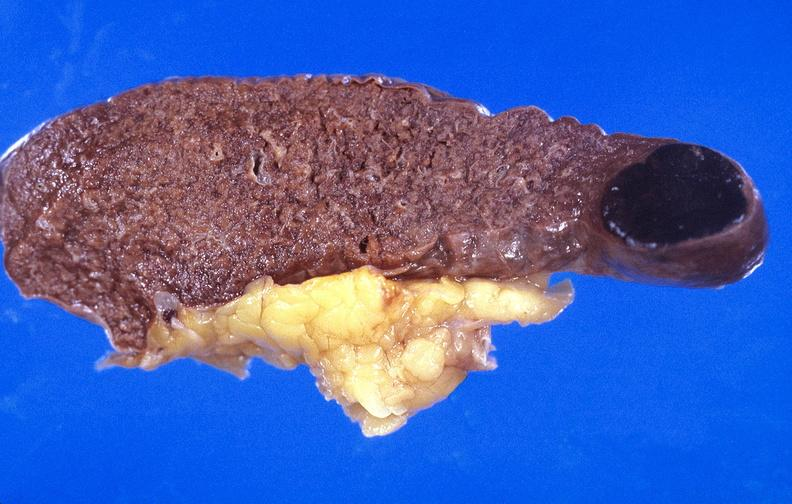s lymphangiomatosis present?
Answer the question using a single word or phrase. No 